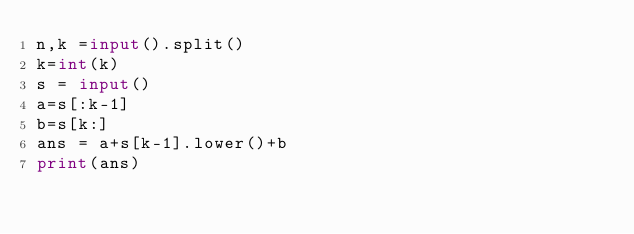Convert code to text. <code><loc_0><loc_0><loc_500><loc_500><_Python_>n,k =input().split()
k=int(k)
s = input()
a=s[:k-1]
b=s[k:]
ans = a+s[k-1].lower()+b
print(ans)</code> 